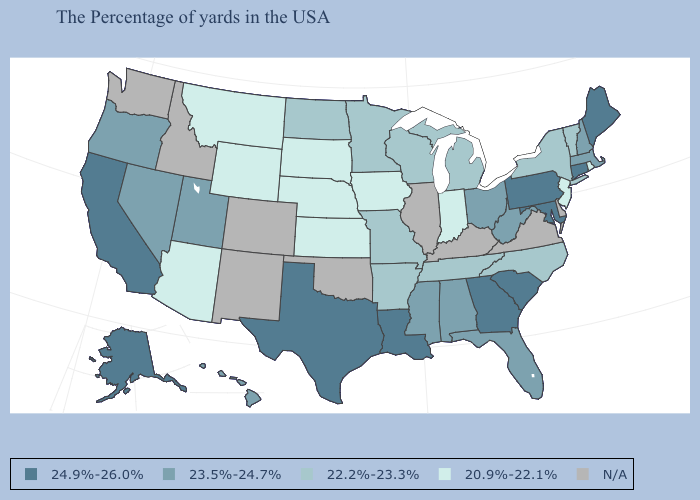Does the map have missing data?
Concise answer only. Yes. Which states have the lowest value in the USA?
Quick response, please. Rhode Island, New Jersey, Indiana, Iowa, Kansas, Nebraska, South Dakota, Wyoming, Montana, Arizona. Name the states that have a value in the range 23.5%-24.7%?
Write a very short answer. Massachusetts, New Hampshire, West Virginia, Ohio, Florida, Alabama, Mississippi, Utah, Nevada, Oregon, Hawaii. Among the states that border North Dakota , which have the highest value?
Keep it brief. Minnesota. Which states hav the highest value in the Northeast?
Quick response, please. Maine, Connecticut, Pennsylvania. Which states have the lowest value in the USA?
Quick response, please. Rhode Island, New Jersey, Indiana, Iowa, Kansas, Nebraska, South Dakota, Wyoming, Montana, Arizona. What is the value of Ohio?
Answer briefly. 23.5%-24.7%. Is the legend a continuous bar?
Quick response, please. No. What is the value of Massachusetts?
Answer briefly. 23.5%-24.7%. What is the value of Virginia?
Quick response, please. N/A. Name the states that have a value in the range 20.9%-22.1%?
Write a very short answer. Rhode Island, New Jersey, Indiana, Iowa, Kansas, Nebraska, South Dakota, Wyoming, Montana, Arizona. What is the highest value in the West ?
Give a very brief answer. 24.9%-26.0%. Which states have the lowest value in the USA?
Answer briefly. Rhode Island, New Jersey, Indiana, Iowa, Kansas, Nebraska, South Dakota, Wyoming, Montana, Arizona. How many symbols are there in the legend?
Concise answer only. 5. 